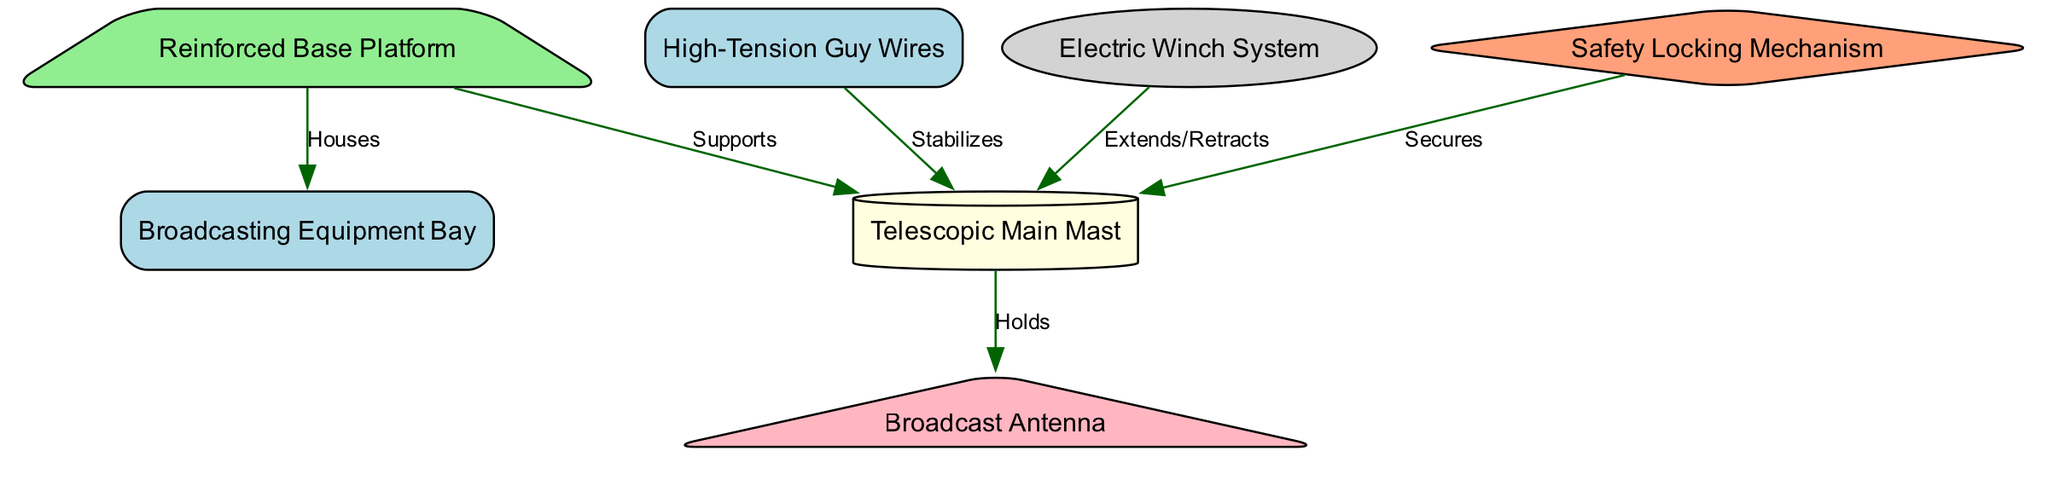What is the label of the node at the base of the structure? The base of the structure is represented by the node labeled "Reinforced Base Platform." In the diagram, each node has a label, and the base node specifically identifies the foundational support of the tower.
Answer: Reinforced Base Platform How many nodes are present in the diagram? To determine the number of nodes, we can count each distinct structure that is represented in the diagram. In this case, the nodes are: Reinforced Base Platform, Telescopic Main Mast, High-Tension Guy Wires, Broadcast Antenna, Electric Winch System, Broadcasting Equipment Bay, and Safety Locking Mechanism. This totals seven nodes.
Answer: 7 What connects the Electric Winch System to the Telescopic Main Mast? The Electric Winch System connects to the Telescopic Main Mast with an edge labeled "Extends/Retracts." Examining the edges in the diagram reveals that this specific action relates to the functionality of the winch system in relation to the main mast.
Answer: Extends/Retracts Which node stabilizes the main mast? The High-Tension Guy Wires feature an edge labeled "Stabilizes" that connects to the Telescopic Main Mast. This indicates that the function of the guy wires is to provide stabilization support to maintain the mast's position.
Answer: High-Tension Guy Wires What type of mechanism secures the main mast? The Safety Locking Mechanism is the specified node that secures the Telescopic Main Mast, as noted by the edge labeled "Secures" connecting them. This edge illustrates the protective feature of the safety mechanism in maintaining the integrity of the tower structure.
Answer: Safety Locking Mechanism Which component houses the Broadcasting Equipment? The node labeled "Broadcasting Equipment Bay" is connected to the Reinforced Base Platform with an edge labeled "Houses." This implies that the broadcasting equipment is physically contained within the base platform of the tower structure.
Answer: Broadcasting Equipment Bay How does the main mast interact with the Broadcast Antenna? The main mast "Holds" the Broadcast Antenna, as indicated by the edge connecting these two nodes. This relationship is crucial because the antenna depends on the mast for elevation and positioning for effective broadcasting.
Answer: Holds What shape represents the Safety Locking Mechanism in the diagram? The Safety Locking Mechanism is depicted as a diamond shape in the diagram. Such specific shapes often help in visually distinguishing different types of components or systems represented within engineering diagrams.
Answer: Diamond 